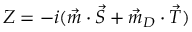Convert formula to latex. <formula><loc_0><loc_0><loc_500><loc_500>Z = - i ( \vec { m } \cdot \vec { S } + \vec { m } _ { D } \cdot \vec { T } )</formula> 